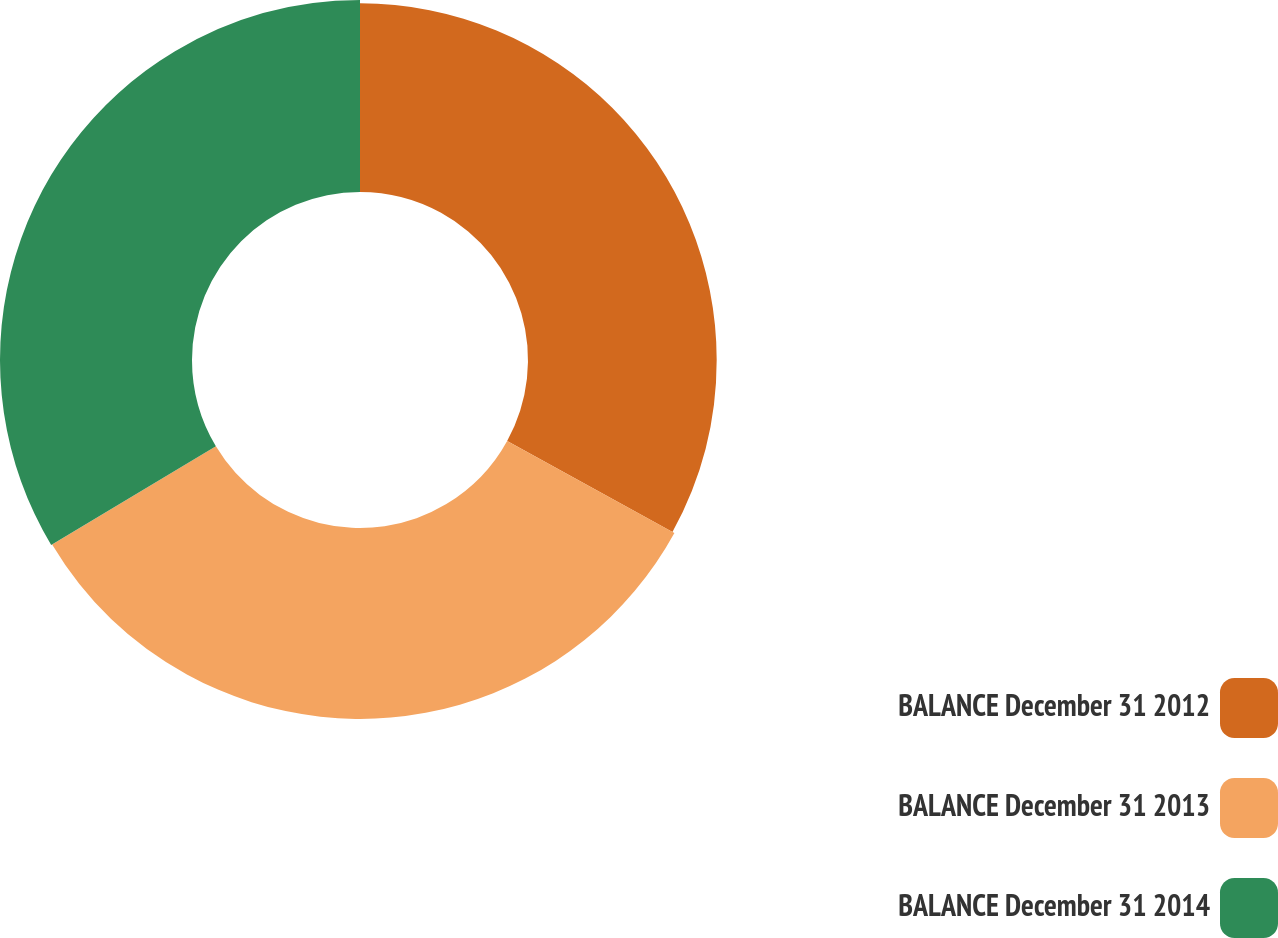Convert chart. <chart><loc_0><loc_0><loc_500><loc_500><pie_chart><fcel>BALANCE December 31 2012<fcel>BALANCE December 31 2013<fcel>BALANCE December 31 2014<nl><fcel>33.01%<fcel>33.4%<fcel>33.59%<nl></chart> 